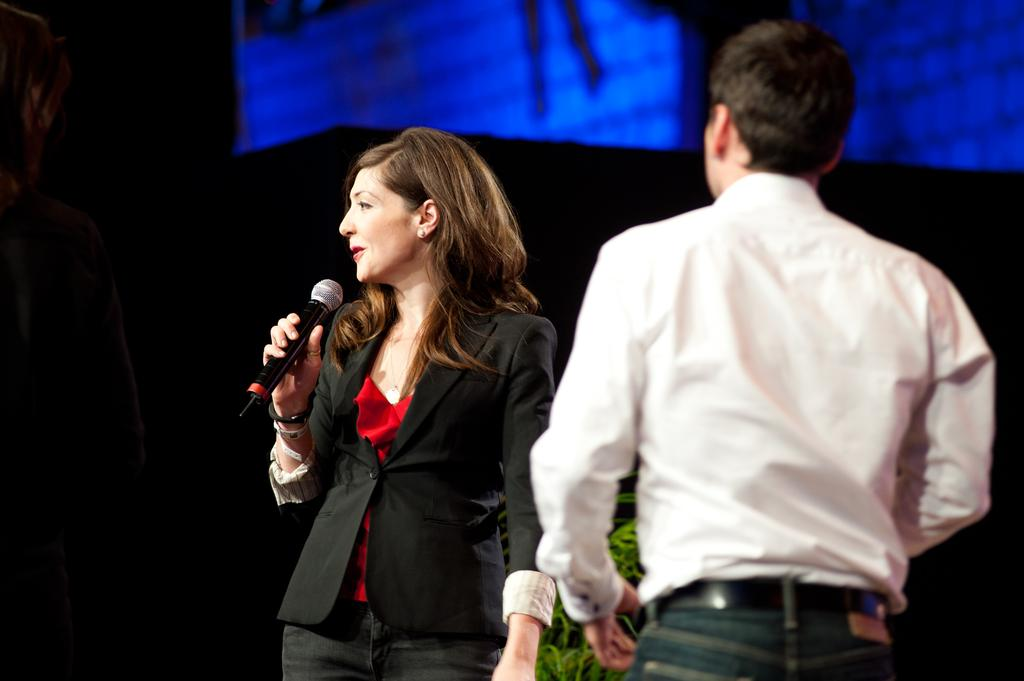What is the main subject of the image? The main subject of the image is a woman. What is the woman doing in the image? The woman is standing and holding a mic in her hand. Is there anyone else in the image? Yes, there is a person standing beside the woman. What can be seen in the background of the image? There are blue color lights in the background. What type of punishment is the woman receiving in the image? There is no indication of punishment in the image; the woman is holding a mic, which suggests she might be performing or speaking. 